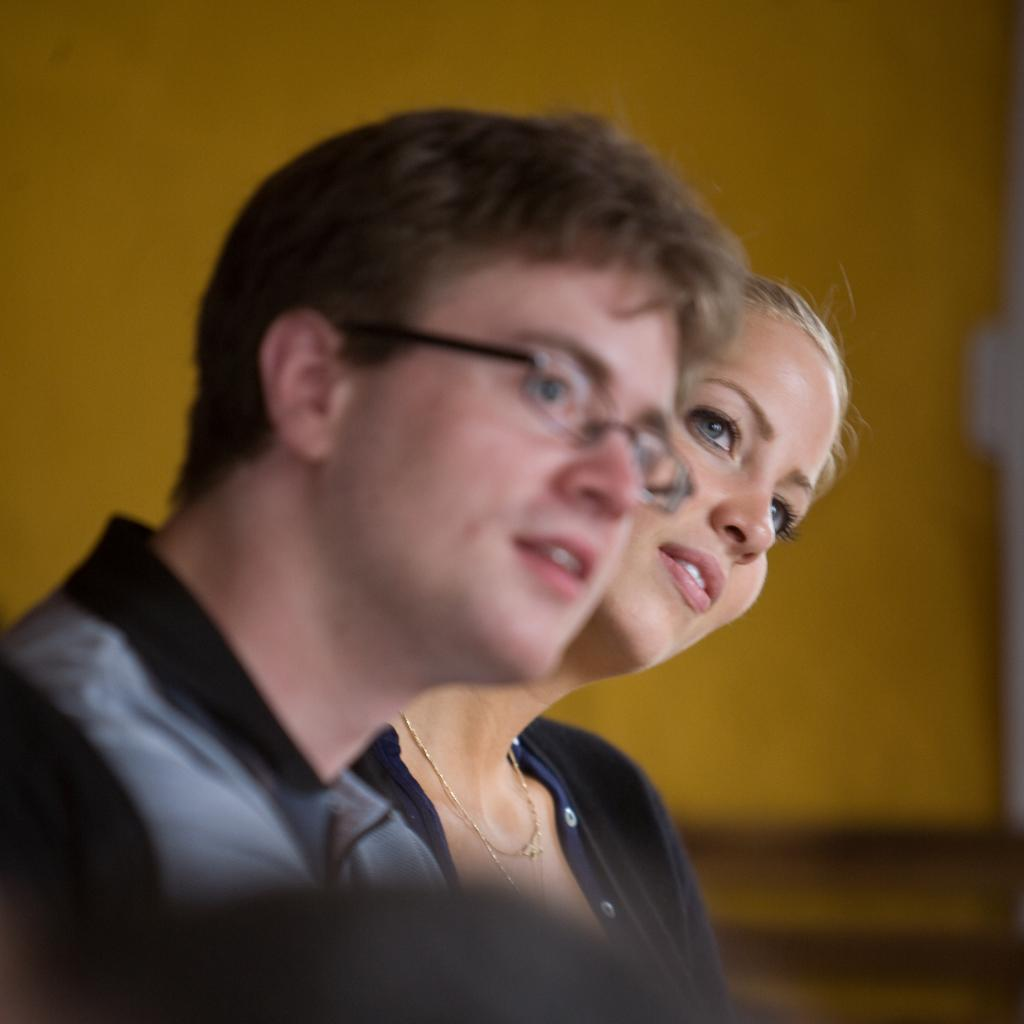Who are the people in the image? There is a man and a lady in the image. What can be seen in the background of the image? There is a wall in the background of the image. What type of whistle can be heard in the image? There is no whistle present in the image, and therefore no sound can be heard. 